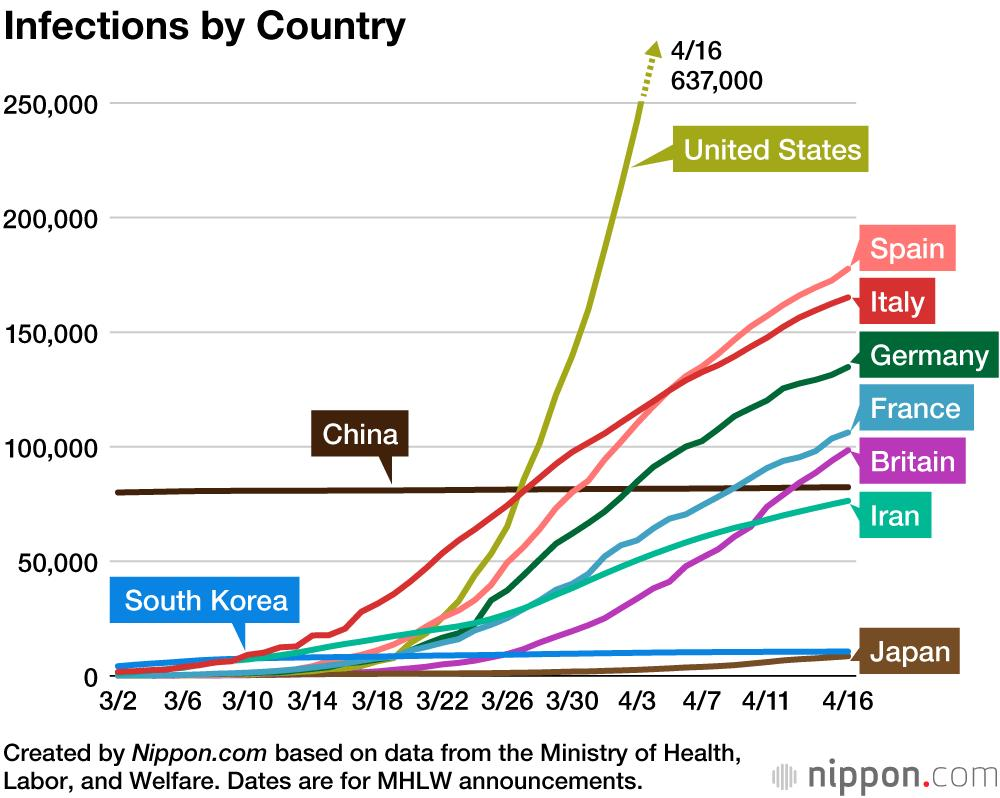Specify some key components in this picture. In China, the number of infections has remained stable. South Korea and Japan have infections below 50,000, according to the data provided. Spain is the second highest country in terms of total number of infections. According to the data, South Korea has the second lowest total number of infections. The United States has the highest rate of increase in infections in the last week of March. 